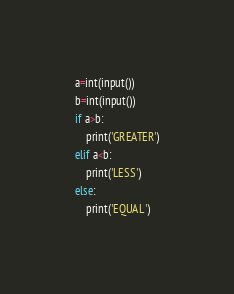Convert code to text. <code><loc_0><loc_0><loc_500><loc_500><_Python_>a=int(input())
b=int(input())
if a>b:
    print('GREATER')
elif a<b:
    print('LESS')
else:
    print('EQUAL')</code> 